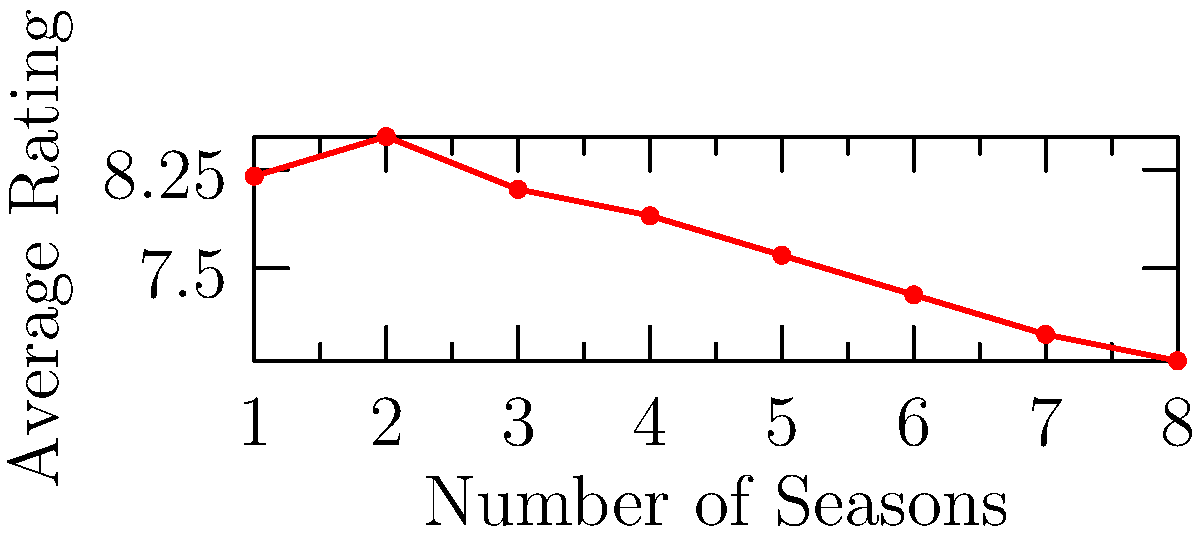Looking at the scatter plot of TV series ratings versus the number of seasons, what trend do you observe in the average ratings as the number of seasons increases? To analyze the trend in this scatter plot, let's follow these steps:

1. Observe the overall pattern: As we move from left to right (increasing number of seasons), we can see that the points generally move downward.

2. Interpret the axes:
   - The x-axis represents the number of seasons, ranging from 1 to 8.
   - The y-axis represents the average rating, ranging from about 6.8 to 8.5.

3. Analyze the data points:
   - The highest rating (about 8.5) is at 2 seasons.
   - The lowest rating (about 6.8) is at 8 seasons.

4. Identify the trend: There is a clear downward trend in ratings as the number of seasons increases.

5. Consider the implications: This suggests that, on average, TV series tend to receive lower ratings in later seasons compared to earlier ones.

Given this analysis, we can conclude that there is a negative correlation between the number of seasons and the average rating of TV series.
Answer: Negative correlation 